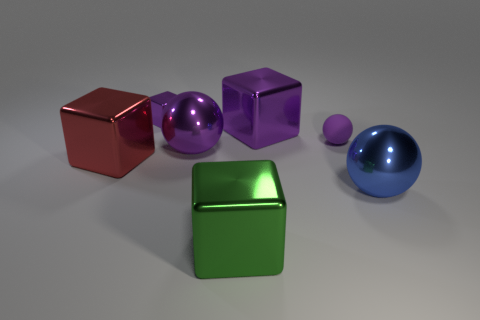Subtract all large cubes. How many cubes are left? 1 Subtract all spheres. How many objects are left? 4 Subtract all red cubes. How many cubes are left? 3 Add 2 big purple balls. How many big purple balls exist? 3 Add 2 big gray metal things. How many objects exist? 9 Subtract 0 purple cylinders. How many objects are left? 7 Subtract 1 blocks. How many blocks are left? 3 Subtract all cyan balls. Subtract all red blocks. How many balls are left? 3 Subtract all gray balls. How many green blocks are left? 1 Subtract all purple rubber spheres. Subtract all big purple metal blocks. How many objects are left? 5 